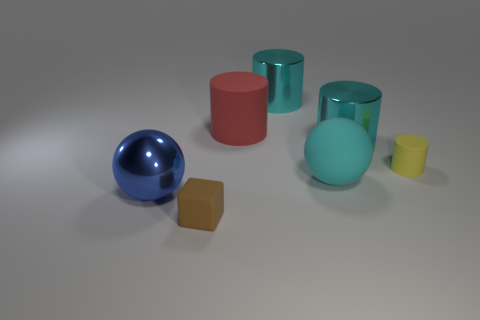Subtract all big red cylinders. How many cylinders are left? 3 Add 1 big cylinders. How many objects exist? 8 Subtract all blue balls. How many balls are left? 1 Subtract all yellow cubes. How many cyan cylinders are left? 2 Subtract 2 cylinders. How many cylinders are left? 2 Add 1 small brown shiny cubes. How many small brown shiny cubes exist? 1 Subtract 1 brown blocks. How many objects are left? 6 Subtract all balls. How many objects are left? 5 Subtract all red cylinders. Subtract all blue cubes. How many cylinders are left? 3 Subtract all big things. Subtract all cyan cylinders. How many objects are left? 0 